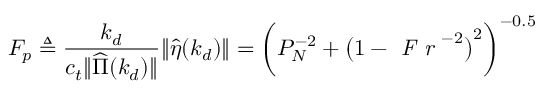Convert formula to latex. <formula><loc_0><loc_0><loc_500><loc_500>F _ { p } \triangle q \frac { k _ { d } } { c _ { t } \| \widehat { \Pi } ( k _ { d } ) \| } \| \hat { \eta } ( k _ { d } ) \| = \left ( P _ { N } ^ { - 2 } + \left ( 1 - F r ^ { - 2 } \right ) ^ { 2 } \right ) ^ { - 0 . 5 }</formula> 